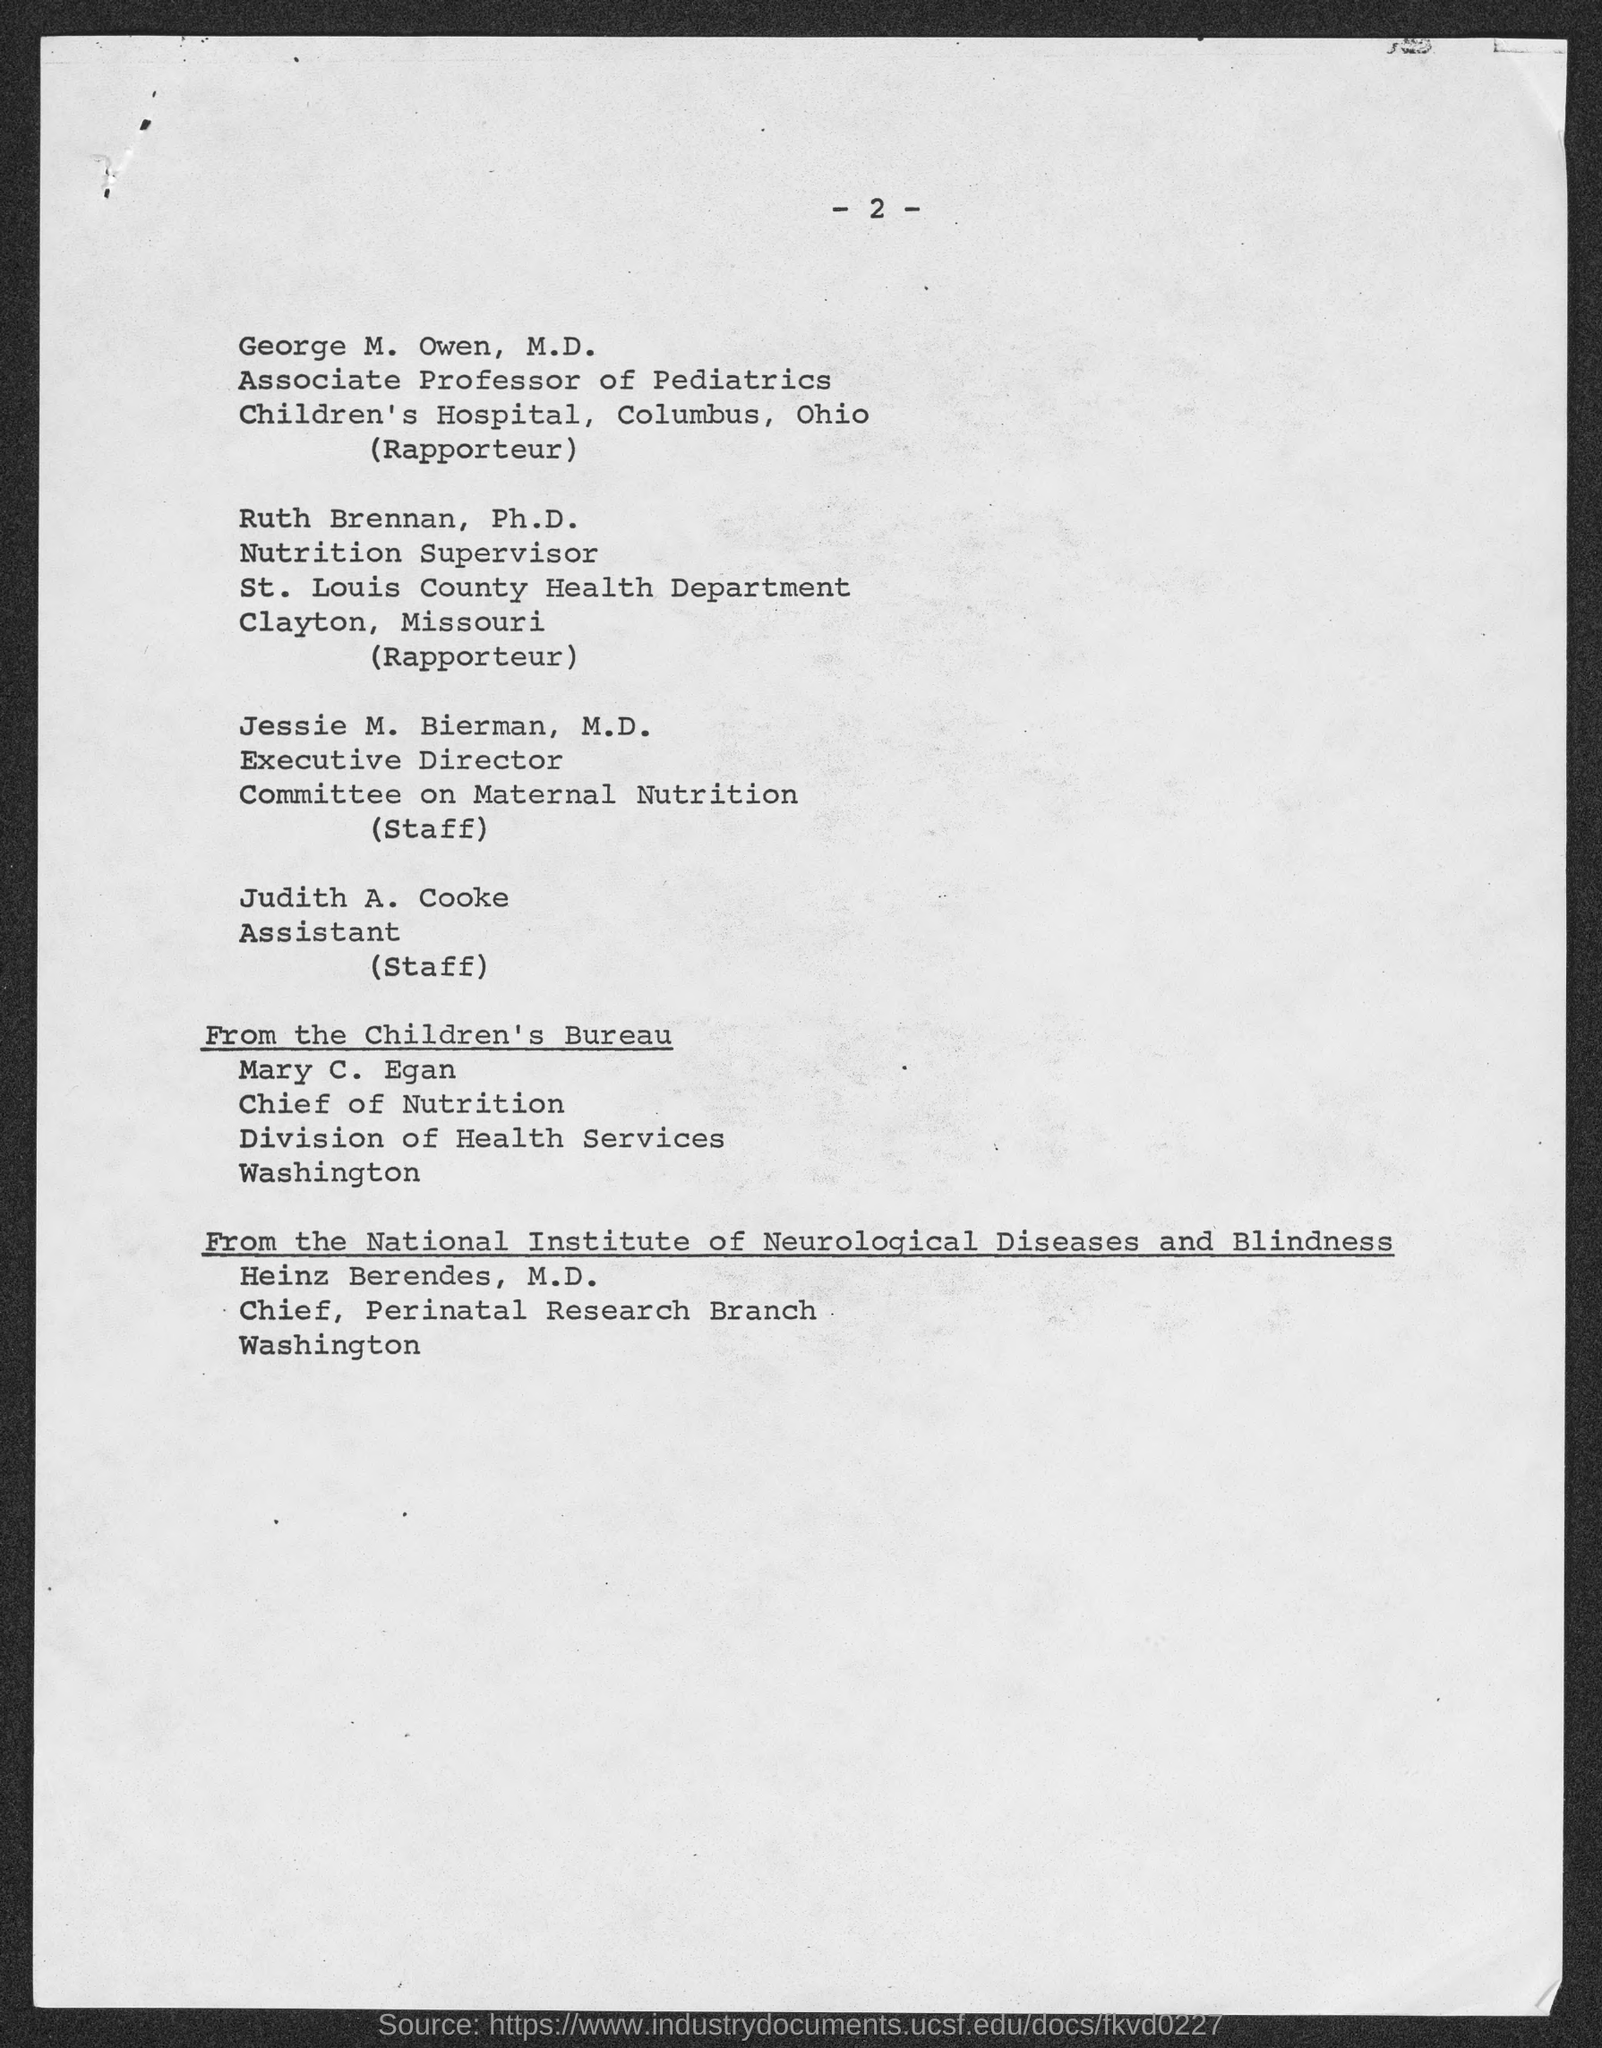List a handful of essential elements in this visual. Jessie M. Bierman, M.D., is the executive director of the committee on maternal nutrition. Judith A. Cooke is the assistant. Mary C. Egan is the chief of nutrition at the division of health services in Washington. The page number is 2, as declared. Heinz Berendes is the chief at the Perinatal Research Branch in Washington. 